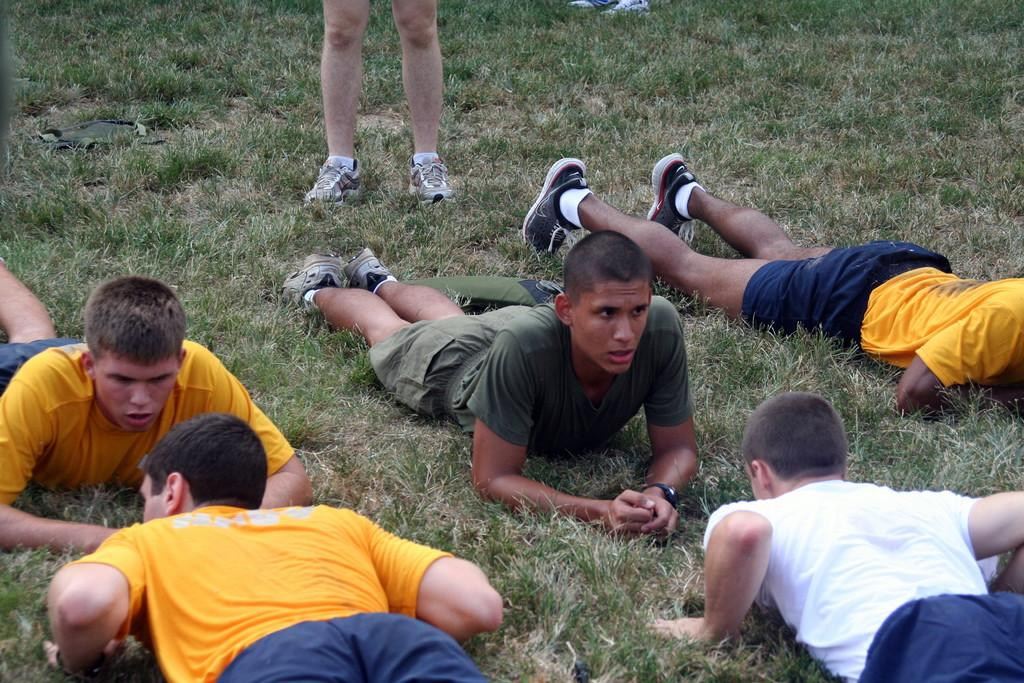What are the people in the image doing? The persons in the image are lying on the ground in the center of the image. Can you describe the position of the person's legs in the image? A person's legs are visible at the top of the image. What type of environment is visible in the background of the image? There is grass in the background of the image. What is the aftermath of the cemetery in the image? There is no cemetery present in the image, so it is not possible to discuss its aftermath. How are the people in the image using the grass? The image does not show the people using the grass in any specific way, so it cannot be determined from the image. 